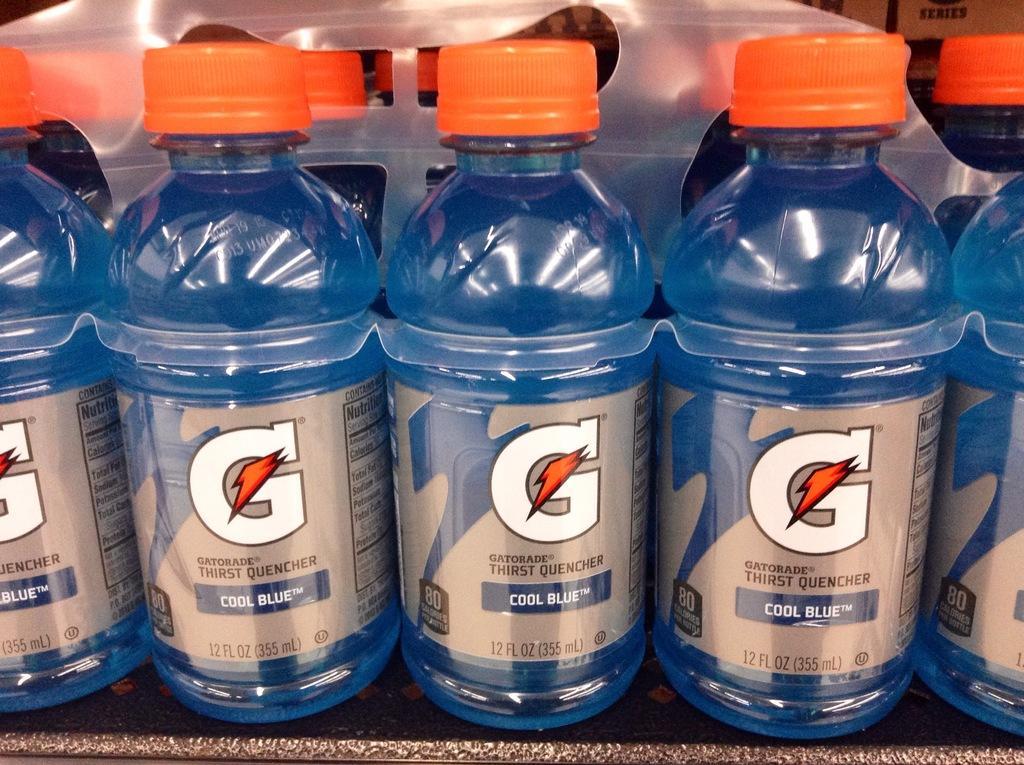In one or two sentences, can you explain what this image depicts? In this image we can see blue color bottles with orange lids. 